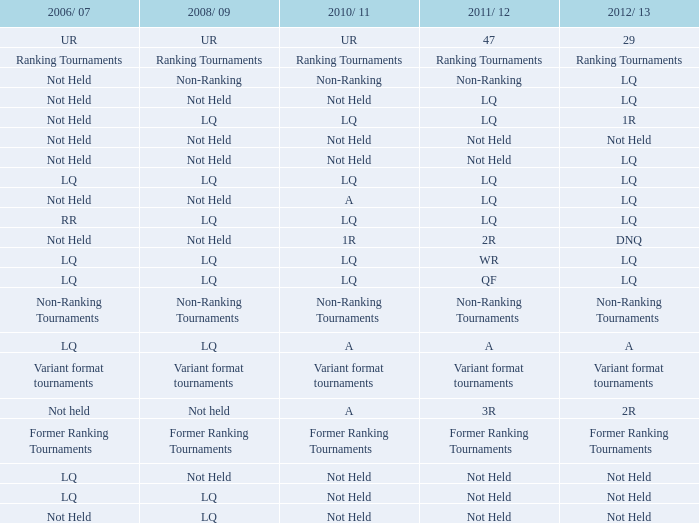What is 2010-11, when 2006/07 is UR? UR. 